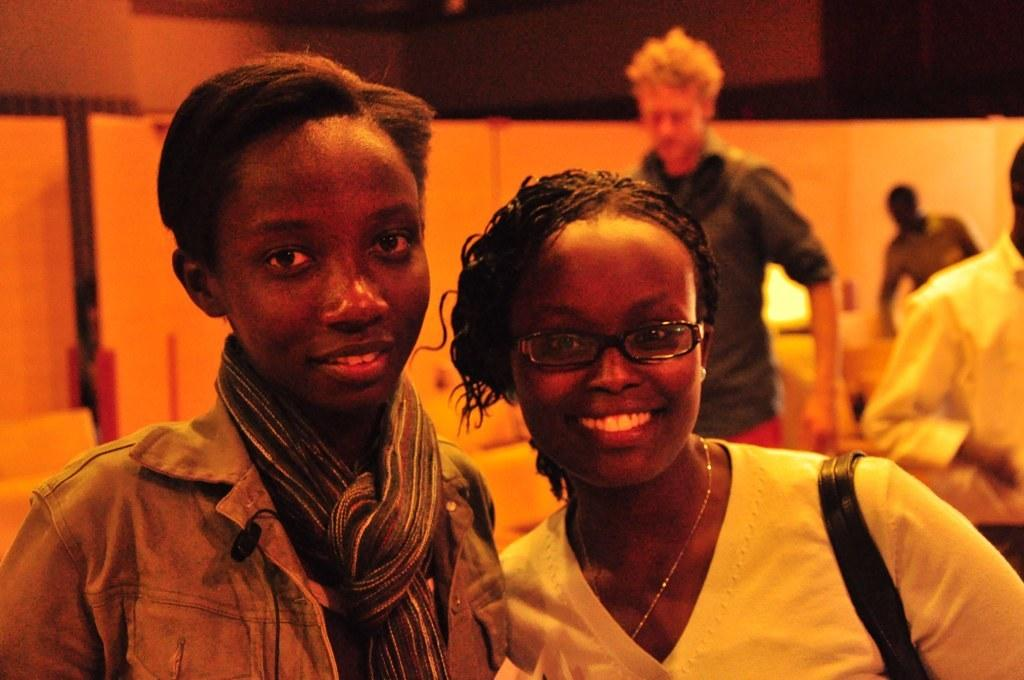What can be observed about the people in the image? There are people wearing clothes in the image. How would you describe the background of the image? The background of the image is blurred. Can you identify any specific details about the woman in the image? The woman is wearing spectacles and a neck chain, and she is carrying a handbag. What type of screw is being used to record the act in the image? There is no screw or act being recorded in the image; it features people wearing clothes with a blurred background. 